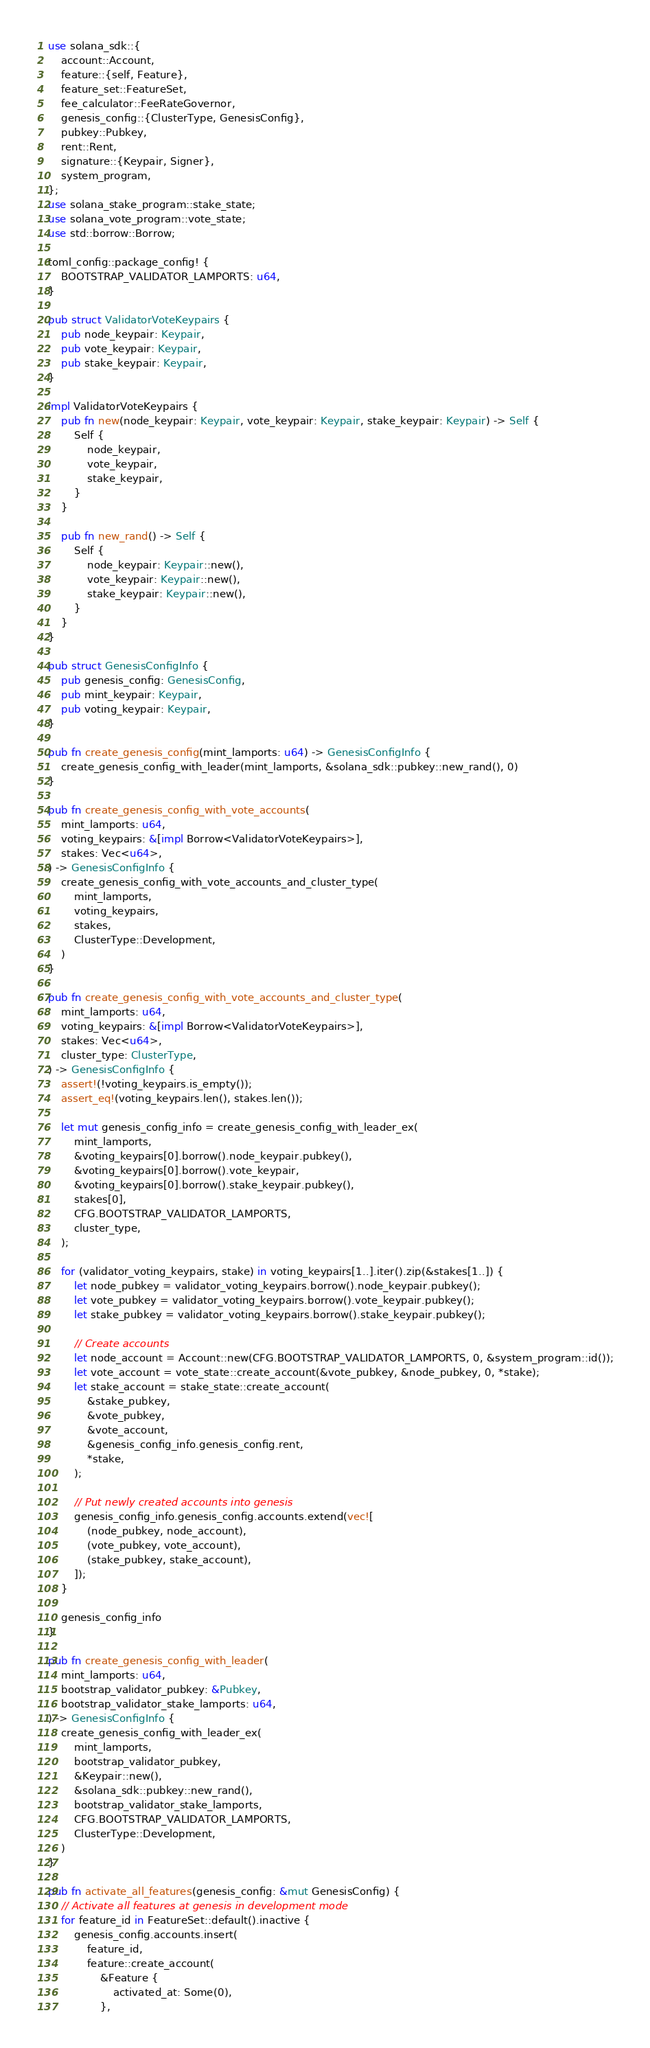<code> <loc_0><loc_0><loc_500><loc_500><_Rust_>use solana_sdk::{
    account::Account,
    feature::{self, Feature},
    feature_set::FeatureSet,
    fee_calculator::FeeRateGovernor,
    genesis_config::{ClusterType, GenesisConfig},
    pubkey::Pubkey,
    rent::Rent,
    signature::{Keypair, Signer},
    system_program,
};
use solana_stake_program::stake_state;
use solana_vote_program::vote_state;
use std::borrow::Borrow;

toml_config::package_config! {
    BOOTSTRAP_VALIDATOR_LAMPORTS: u64,
}

pub struct ValidatorVoteKeypairs {
    pub node_keypair: Keypair,
    pub vote_keypair: Keypair,
    pub stake_keypair: Keypair,
}

impl ValidatorVoteKeypairs {
    pub fn new(node_keypair: Keypair, vote_keypair: Keypair, stake_keypair: Keypair) -> Self {
        Self {
            node_keypair,
            vote_keypair,
            stake_keypair,
        }
    }

    pub fn new_rand() -> Self {
        Self {
            node_keypair: Keypair::new(),
            vote_keypair: Keypair::new(),
            stake_keypair: Keypair::new(),
        }
    }
}

pub struct GenesisConfigInfo {
    pub genesis_config: GenesisConfig,
    pub mint_keypair: Keypair,
    pub voting_keypair: Keypair,
}

pub fn create_genesis_config(mint_lamports: u64) -> GenesisConfigInfo {
    create_genesis_config_with_leader(mint_lamports, &solana_sdk::pubkey::new_rand(), 0)
}

pub fn create_genesis_config_with_vote_accounts(
    mint_lamports: u64,
    voting_keypairs: &[impl Borrow<ValidatorVoteKeypairs>],
    stakes: Vec<u64>,
) -> GenesisConfigInfo {
    create_genesis_config_with_vote_accounts_and_cluster_type(
        mint_lamports,
        voting_keypairs,
        stakes,
        ClusterType::Development,
    )
}

pub fn create_genesis_config_with_vote_accounts_and_cluster_type(
    mint_lamports: u64,
    voting_keypairs: &[impl Borrow<ValidatorVoteKeypairs>],
    stakes: Vec<u64>,
    cluster_type: ClusterType,
) -> GenesisConfigInfo {
    assert!(!voting_keypairs.is_empty());
    assert_eq!(voting_keypairs.len(), stakes.len());

    let mut genesis_config_info = create_genesis_config_with_leader_ex(
        mint_lamports,
        &voting_keypairs[0].borrow().node_keypair.pubkey(),
        &voting_keypairs[0].borrow().vote_keypair,
        &voting_keypairs[0].borrow().stake_keypair.pubkey(),
        stakes[0],
        CFG.BOOTSTRAP_VALIDATOR_LAMPORTS,
        cluster_type,
    );

    for (validator_voting_keypairs, stake) in voting_keypairs[1..].iter().zip(&stakes[1..]) {
        let node_pubkey = validator_voting_keypairs.borrow().node_keypair.pubkey();
        let vote_pubkey = validator_voting_keypairs.borrow().vote_keypair.pubkey();
        let stake_pubkey = validator_voting_keypairs.borrow().stake_keypair.pubkey();

        // Create accounts
        let node_account = Account::new(CFG.BOOTSTRAP_VALIDATOR_LAMPORTS, 0, &system_program::id());
        let vote_account = vote_state::create_account(&vote_pubkey, &node_pubkey, 0, *stake);
        let stake_account = stake_state::create_account(
            &stake_pubkey,
            &vote_pubkey,
            &vote_account,
            &genesis_config_info.genesis_config.rent,
            *stake,
        );

        // Put newly created accounts into genesis
        genesis_config_info.genesis_config.accounts.extend(vec![
            (node_pubkey, node_account),
            (vote_pubkey, vote_account),
            (stake_pubkey, stake_account),
        ]);
    }

    genesis_config_info
}

pub fn create_genesis_config_with_leader(
    mint_lamports: u64,
    bootstrap_validator_pubkey: &Pubkey,
    bootstrap_validator_stake_lamports: u64,
) -> GenesisConfigInfo {
    create_genesis_config_with_leader_ex(
        mint_lamports,
        bootstrap_validator_pubkey,
        &Keypair::new(),
        &solana_sdk::pubkey::new_rand(),
        bootstrap_validator_stake_lamports,
        CFG.BOOTSTRAP_VALIDATOR_LAMPORTS,
        ClusterType::Development,
    )
}

pub fn activate_all_features(genesis_config: &mut GenesisConfig) {
    // Activate all features at genesis in development mode
    for feature_id in FeatureSet::default().inactive {
        genesis_config.accounts.insert(
            feature_id,
            feature::create_account(
                &Feature {
                    activated_at: Some(0),
                },</code> 